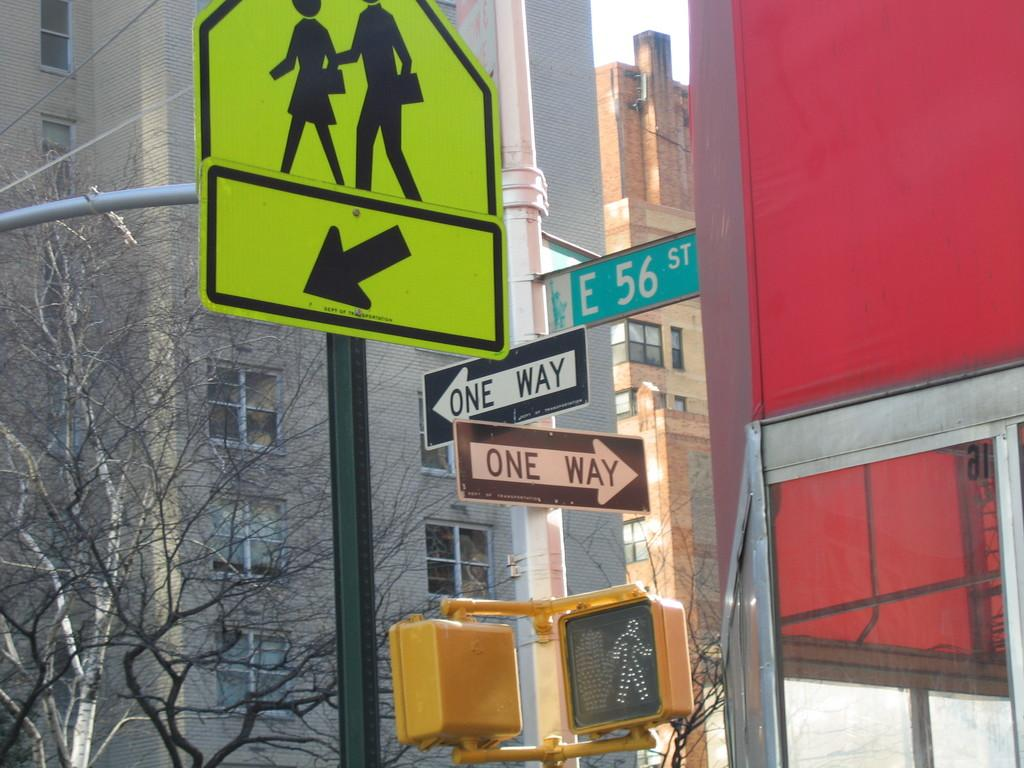<image>
Render a clear and concise summary of the photo. E. 56 St. is a one way street intersected by another one way street. 